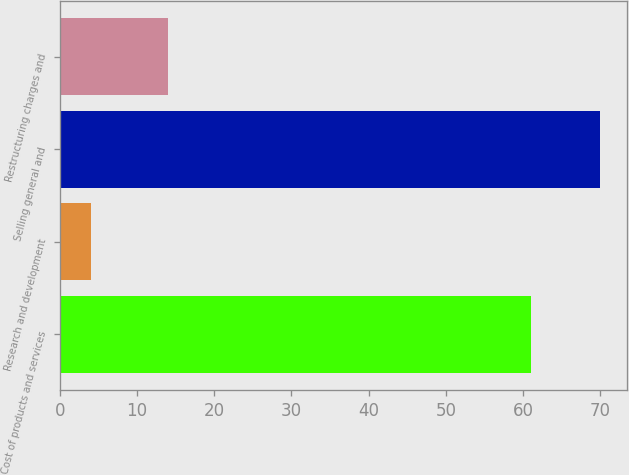Convert chart. <chart><loc_0><loc_0><loc_500><loc_500><bar_chart><fcel>Cost of products and services<fcel>Research and development<fcel>Selling general and<fcel>Restructuring charges and<nl><fcel>61<fcel>4<fcel>70<fcel>14<nl></chart> 